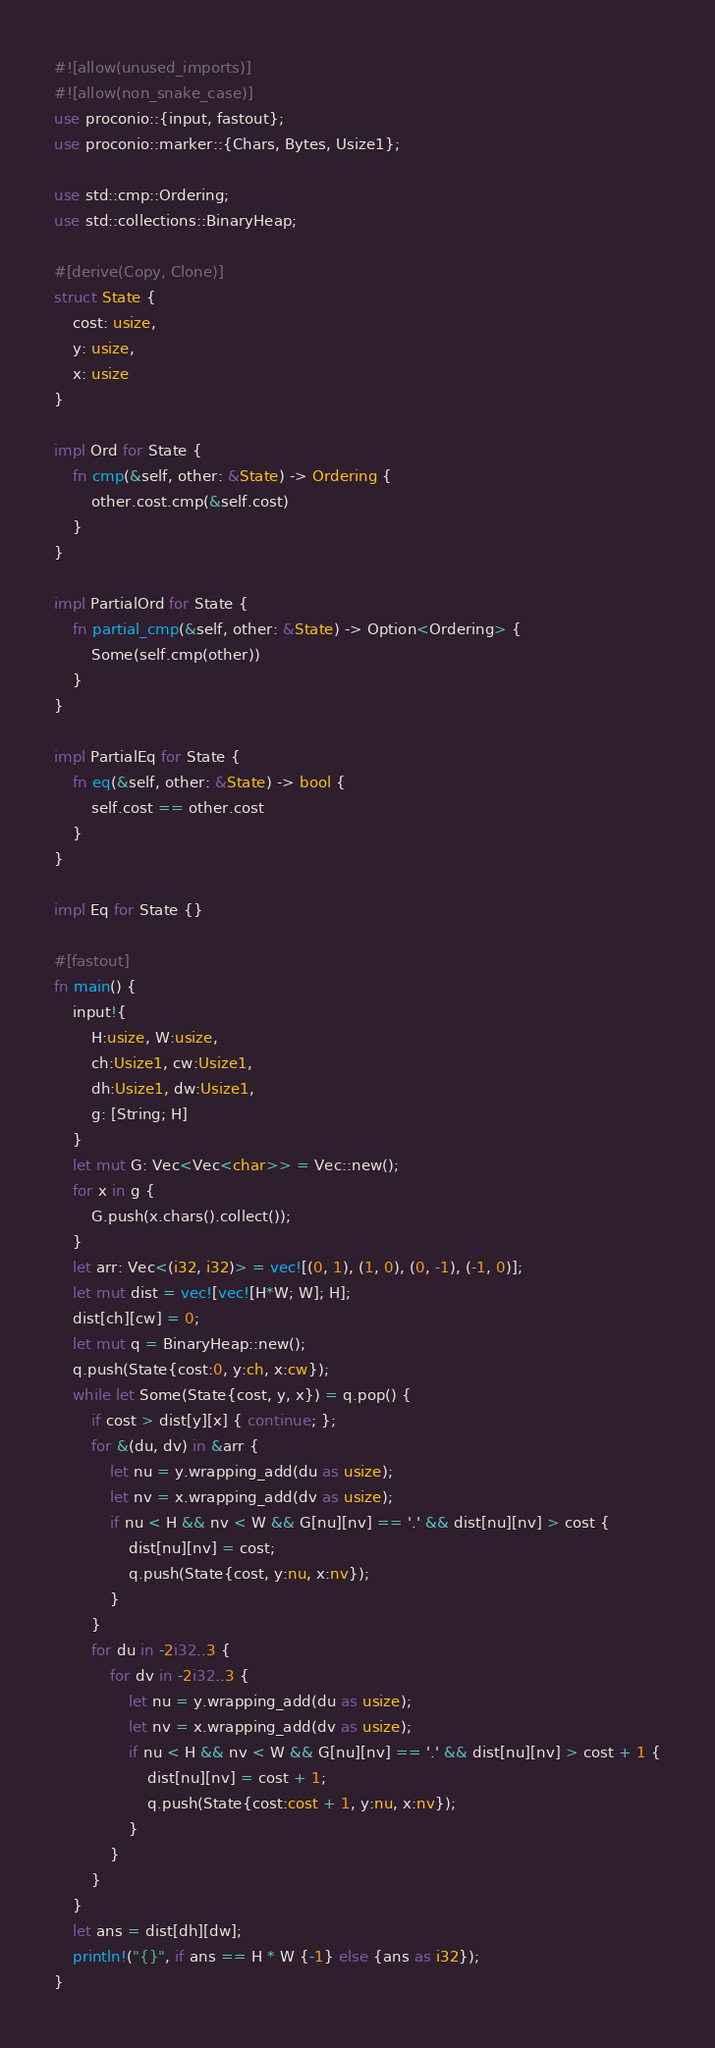<code> <loc_0><loc_0><loc_500><loc_500><_Rust_>#![allow(unused_imports)]
#![allow(non_snake_case)]
use proconio::{input, fastout};
use proconio::marker::{Chars, Bytes, Usize1};

use std::cmp::Ordering;
use std::collections::BinaryHeap;

#[derive(Copy, Clone)]
struct State {
    cost: usize,
    y: usize,
    x: usize
}

impl Ord for State {
    fn cmp(&self, other: &State) -> Ordering {
        other.cost.cmp(&self.cost)
    }
}

impl PartialOrd for State {
    fn partial_cmp(&self, other: &State) -> Option<Ordering> {
        Some(self.cmp(other))
    }
}

impl PartialEq for State {
    fn eq(&self, other: &State) -> bool {
        self.cost == other.cost
    }
}

impl Eq for State {}

#[fastout]
fn main() {
    input!{
        H:usize, W:usize,
        ch:Usize1, cw:Usize1,
        dh:Usize1, dw:Usize1,
        g: [String; H]
    }
    let mut G: Vec<Vec<char>> = Vec::new();
    for x in g {
        G.push(x.chars().collect());
    }
    let arr: Vec<(i32, i32)> = vec![(0, 1), (1, 0), (0, -1), (-1, 0)];
    let mut dist = vec![vec![H*W; W]; H];
    dist[ch][cw] = 0;
    let mut q = BinaryHeap::new();
    q.push(State{cost:0, y:ch, x:cw});
    while let Some(State{cost, y, x}) = q.pop() {
        if cost > dist[y][x] { continue; };
        for &(du, dv) in &arr {
            let nu = y.wrapping_add(du as usize);
            let nv = x.wrapping_add(dv as usize);
            if nu < H && nv < W && G[nu][nv] == '.' && dist[nu][nv] > cost {
                dist[nu][nv] = cost;
                q.push(State{cost, y:nu, x:nv});
            }
        }
        for du in -2i32..3 {
            for dv in -2i32..3 {
                let nu = y.wrapping_add(du as usize);
                let nv = x.wrapping_add(dv as usize);
                if nu < H && nv < W && G[nu][nv] == '.' && dist[nu][nv] > cost + 1 {
                    dist[nu][nv] = cost + 1;
                    q.push(State{cost:cost + 1, y:nu, x:nv});
                }
            }
        }
    }
    let ans = dist[dh][dw];
    println!("{}", if ans == H * W {-1} else {ans as i32});
}
</code> 